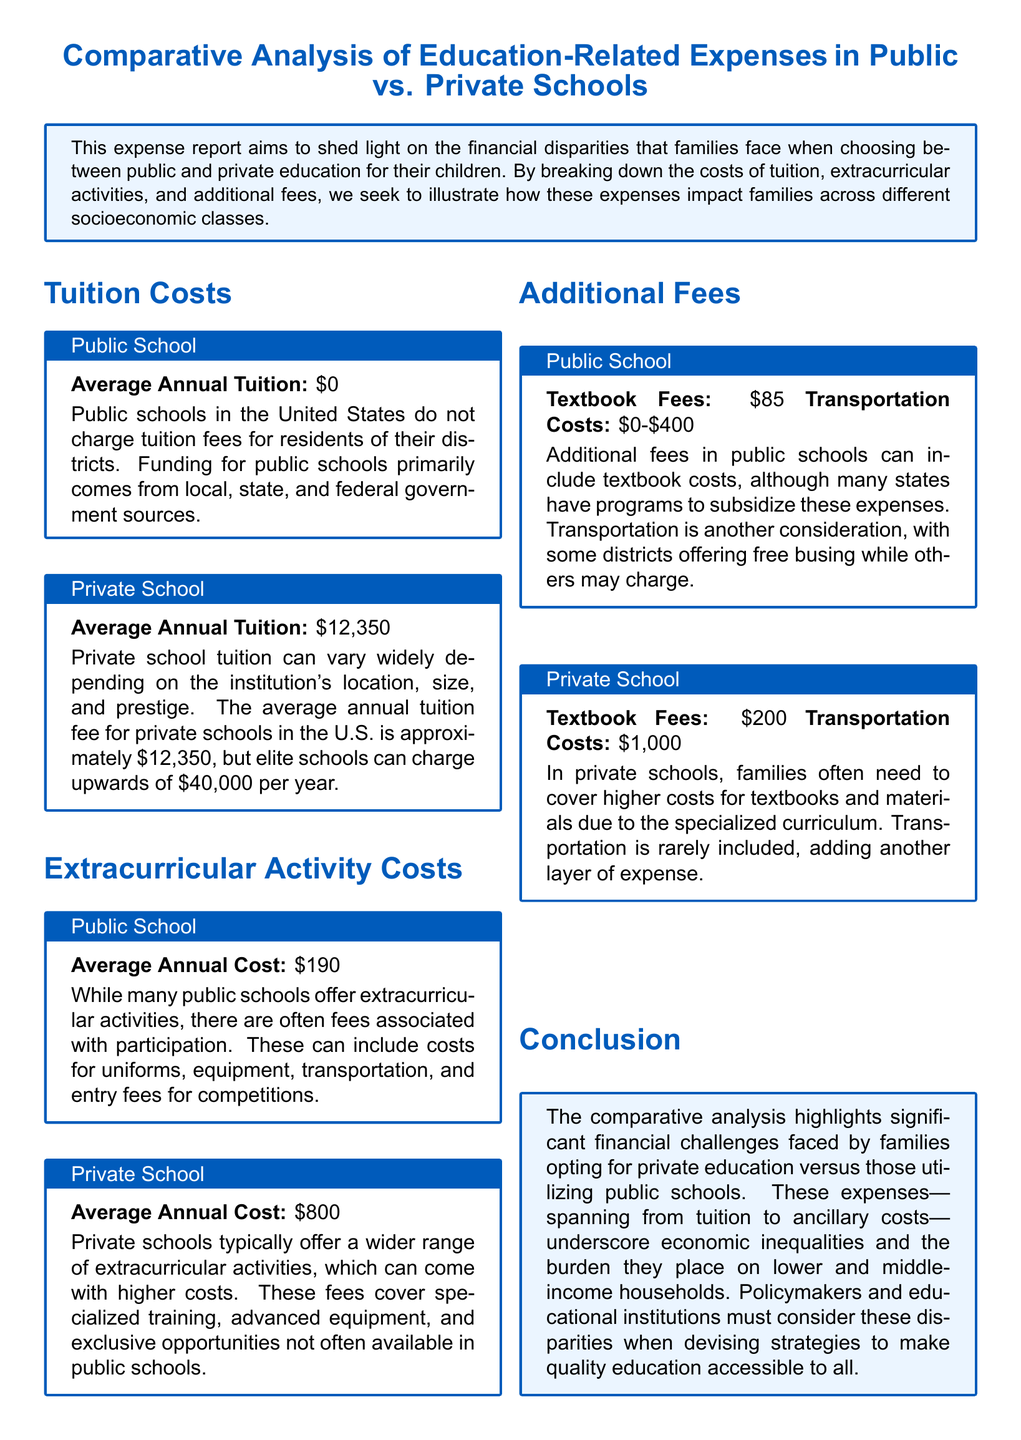What is the average annual tuition for public schools? Public schools do not charge tuition fees for residents of their districts.
Answer: $0 What is the average annual tuition for private schools? The average annual tuition fee for private schools in the U.S. is approximately $12,350.
Answer: $12,350 What is the average annual cost of extracurricular activities in public schools? The report states that public schools have associated costs for extracurricular activities, which average $190.
Answer: $190 What is the average annual cost of extracurricular activities in private schools? Private schools have a higher average cost for extracurricular activities, which is $800.
Answer: $800 What are the textbook fees for public schools? The textbook fees listed in the report for public schools are $85.
Answer: $85 What are the transportation costs for private schools? In private schools, transportation costs are generally around $1,000.
Answer: $1,000 What fee can vary significantly in public schools? Transportation costs in public schools can vary between $0 and $400.
Answer: $0-$400 What conclusion does the report draw about educational expenses? The report highlights significant financial challenges faced by families opting for private education versus those utilizing public schools.
Answer: Financial challenges What responsibility do policymakers have according to the report? Policymakers must consider the disparities in education costs when devising strategies to make quality education accessible to all.
Answer: Consider disparities 